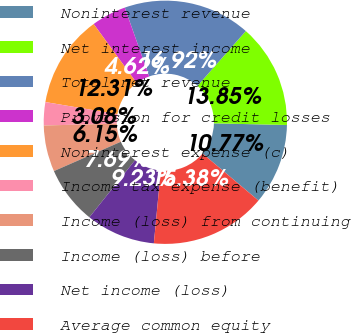<chart> <loc_0><loc_0><loc_500><loc_500><pie_chart><fcel>Noninterest revenue<fcel>Net interest income<fcel>Total net revenue<fcel>Provision for credit losses<fcel>Noninterest expense (c)<fcel>Income tax expense (benefit)<fcel>Income (loss) from continuing<fcel>Income (loss) before<fcel>Net income (loss)<fcel>Average common equity<nl><fcel>10.77%<fcel>13.85%<fcel>16.92%<fcel>4.62%<fcel>12.31%<fcel>3.08%<fcel>6.15%<fcel>7.69%<fcel>9.23%<fcel>15.38%<nl></chart> 